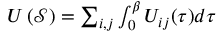<formula> <loc_0><loc_0><loc_500><loc_500>\begin{array} { r } { U \left ( \mathcal { S } \right ) = \sum _ { i , j } \int _ { 0 } ^ { \beta } U _ { i j } ( \tau ) d \tau } \end{array}</formula> 